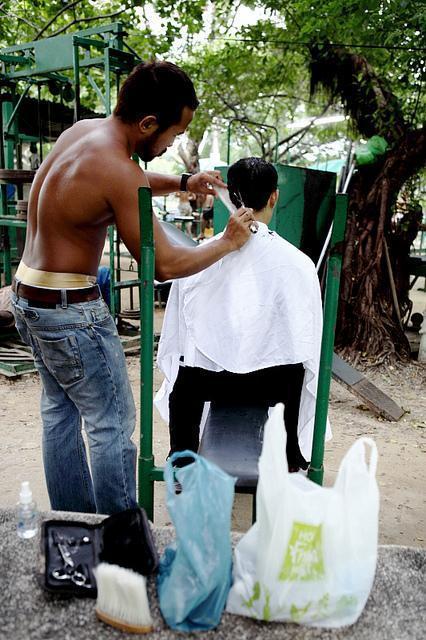How many bags are there?
Give a very brief answer. 2. How many people are visible?
Give a very brief answer. 2. 